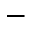<formula> <loc_0><loc_0><loc_500><loc_500>-</formula> 